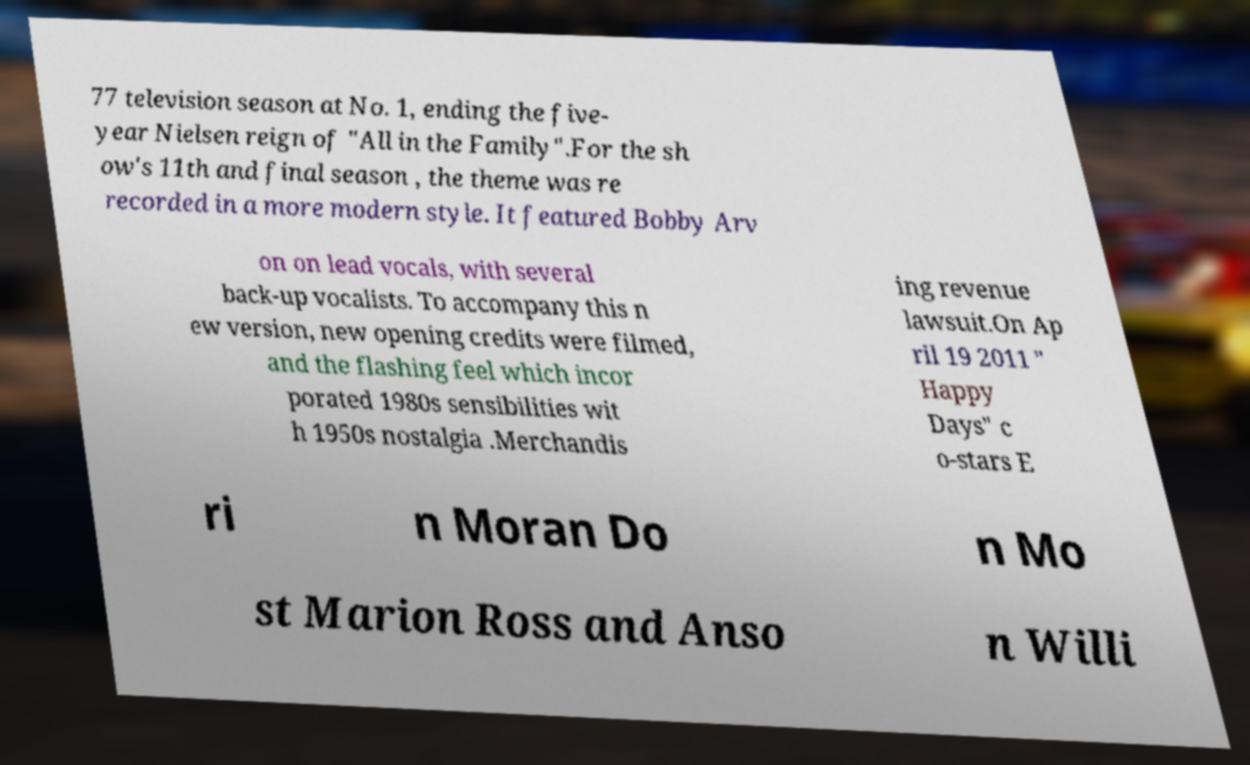For documentation purposes, I need the text within this image transcribed. Could you provide that? 77 television season at No. 1, ending the five- year Nielsen reign of "All in the Family".For the sh ow's 11th and final season , the theme was re recorded in a more modern style. It featured Bobby Arv on on lead vocals, with several back-up vocalists. To accompany this n ew version, new opening credits were filmed, and the flashing feel which incor porated 1980s sensibilities wit h 1950s nostalgia .Merchandis ing revenue lawsuit.On Ap ril 19 2011 " Happy Days" c o-stars E ri n Moran Do n Mo st Marion Ross and Anso n Willi 